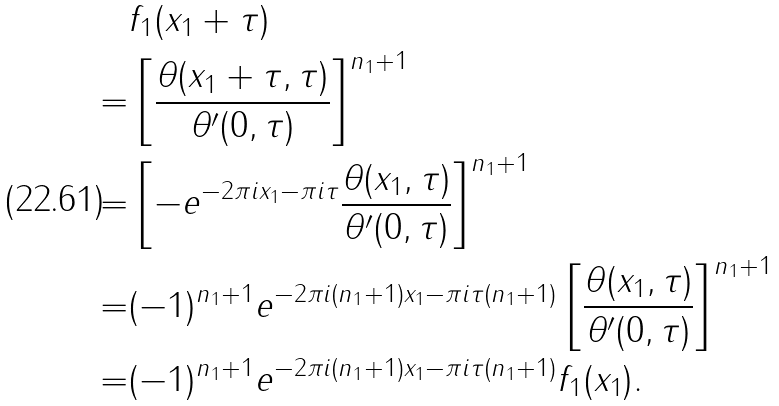Convert formula to latex. <formula><loc_0><loc_0><loc_500><loc_500>& f _ { 1 } ( x _ { 1 } + \tau ) \\ = & \left [ \frac { \theta ( x _ { 1 } + \tau , \tau ) } { \theta ^ { \prime } ( 0 , \tau ) } \right ] ^ { n _ { 1 } + 1 } \\ = & \left [ - e ^ { - 2 \pi i x _ { 1 } - \pi i \tau } \frac { \theta ( x _ { 1 } , \tau ) } { \theta ^ { \prime } ( 0 , \tau ) } \right ] ^ { n _ { 1 } + 1 } \\ = & ( - 1 ) ^ { n _ { 1 } + 1 } e ^ { - 2 \pi i ( n _ { 1 } + 1 ) x _ { 1 } - \pi i \tau ( n _ { 1 } + 1 ) } \left [ \frac { \theta ( x _ { 1 } , \tau ) } { \theta ^ { \prime } ( 0 , \tau ) } \right ] ^ { n _ { 1 } + 1 } \\ = & ( - 1 ) ^ { n _ { 1 } + 1 } e ^ { - 2 \pi i ( n _ { 1 } + 1 ) x _ { 1 } - \pi i \tau ( n _ { 1 } + 1 ) } f _ { 1 } ( x _ { 1 } ) .</formula> 